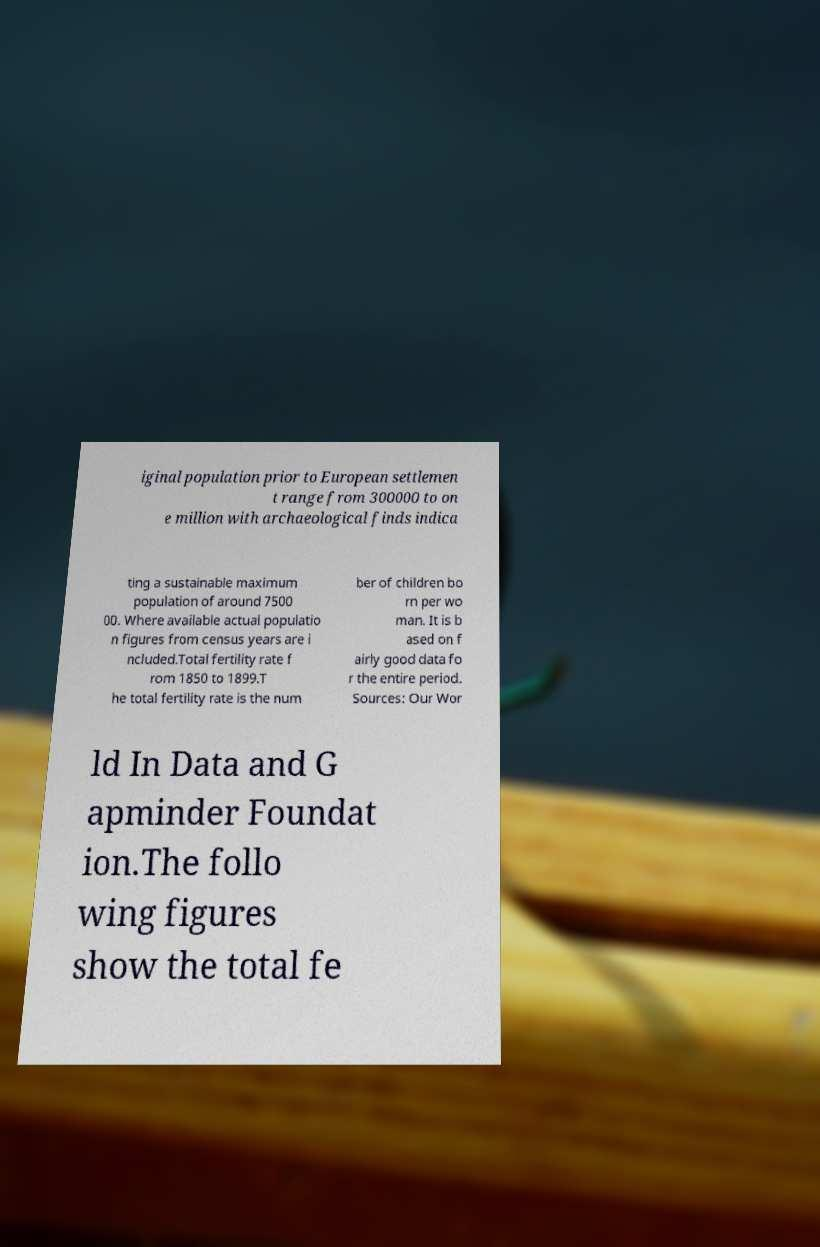Can you read and provide the text displayed in the image?This photo seems to have some interesting text. Can you extract and type it out for me? iginal population prior to European settlemen t range from 300000 to on e million with archaeological finds indica ting a sustainable maximum population of around 7500 00. Where available actual populatio n figures from census years are i ncluded.Total fertility rate f rom 1850 to 1899.T he total fertility rate is the num ber of children bo rn per wo man. It is b ased on f airly good data fo r the entire period. Sources: Our Wor ld In Data and G apminder Foundat ion.The follo wing figures show the total fe 